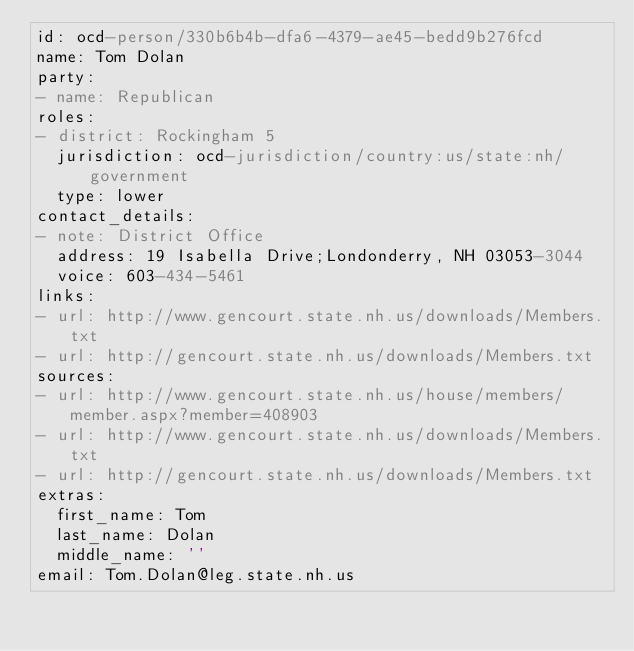<code> <loc_0><loc_0><loc_500><loc_500><_YAML_>id: ocd-person/330b6b4b-dfa6-4379-ae45-bedd9b276fcd
name: Tom Dolan
party:
- name: Republican
roles:
- district: Rockingham 5
  jurisdiction: ocd-jurisdiction/country:us/state:nh/government
  type: lower
contact_details:
- note: District Office
  address: 19 Isabella Drive;Londonderry, NH 03053-3044
  voice: 603-434-5461
links:
- url: http://www.gencourt.state.nh.us/downloads/Members.txt
- url: http://gencourt.state.nh.us/downloads/Members.txt
sources:
- url: http://www.gencourt.state.nh.us/house/members/member.aspx?member=408903
- url: http://www.gencourt.state.nh.us/downloads/Members.txt
- url: http://gencourt.state.nh.us/downloads/Members.txt
extras:
  first_name: Tom
  last_name: Dolan
  middle_name: ''
email: Tom.Dolan@leg.state.nh.us
</code> 